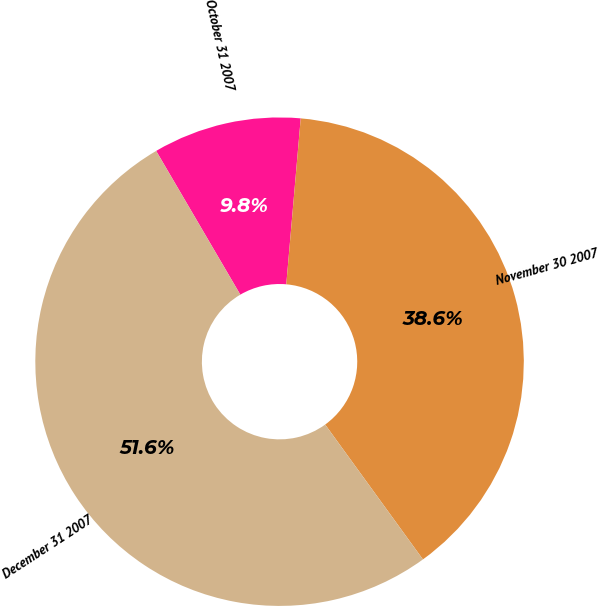Convert chart. <chart><loc_0><loc_0><loc_500><loc_500><pie_chart><fcel>October 31 2007<fcel>November 30 2007<fcel>December 31 2007<nl><fcel>9.81%<fcel>38.63%<fcel>51.55%<nl></chart> 